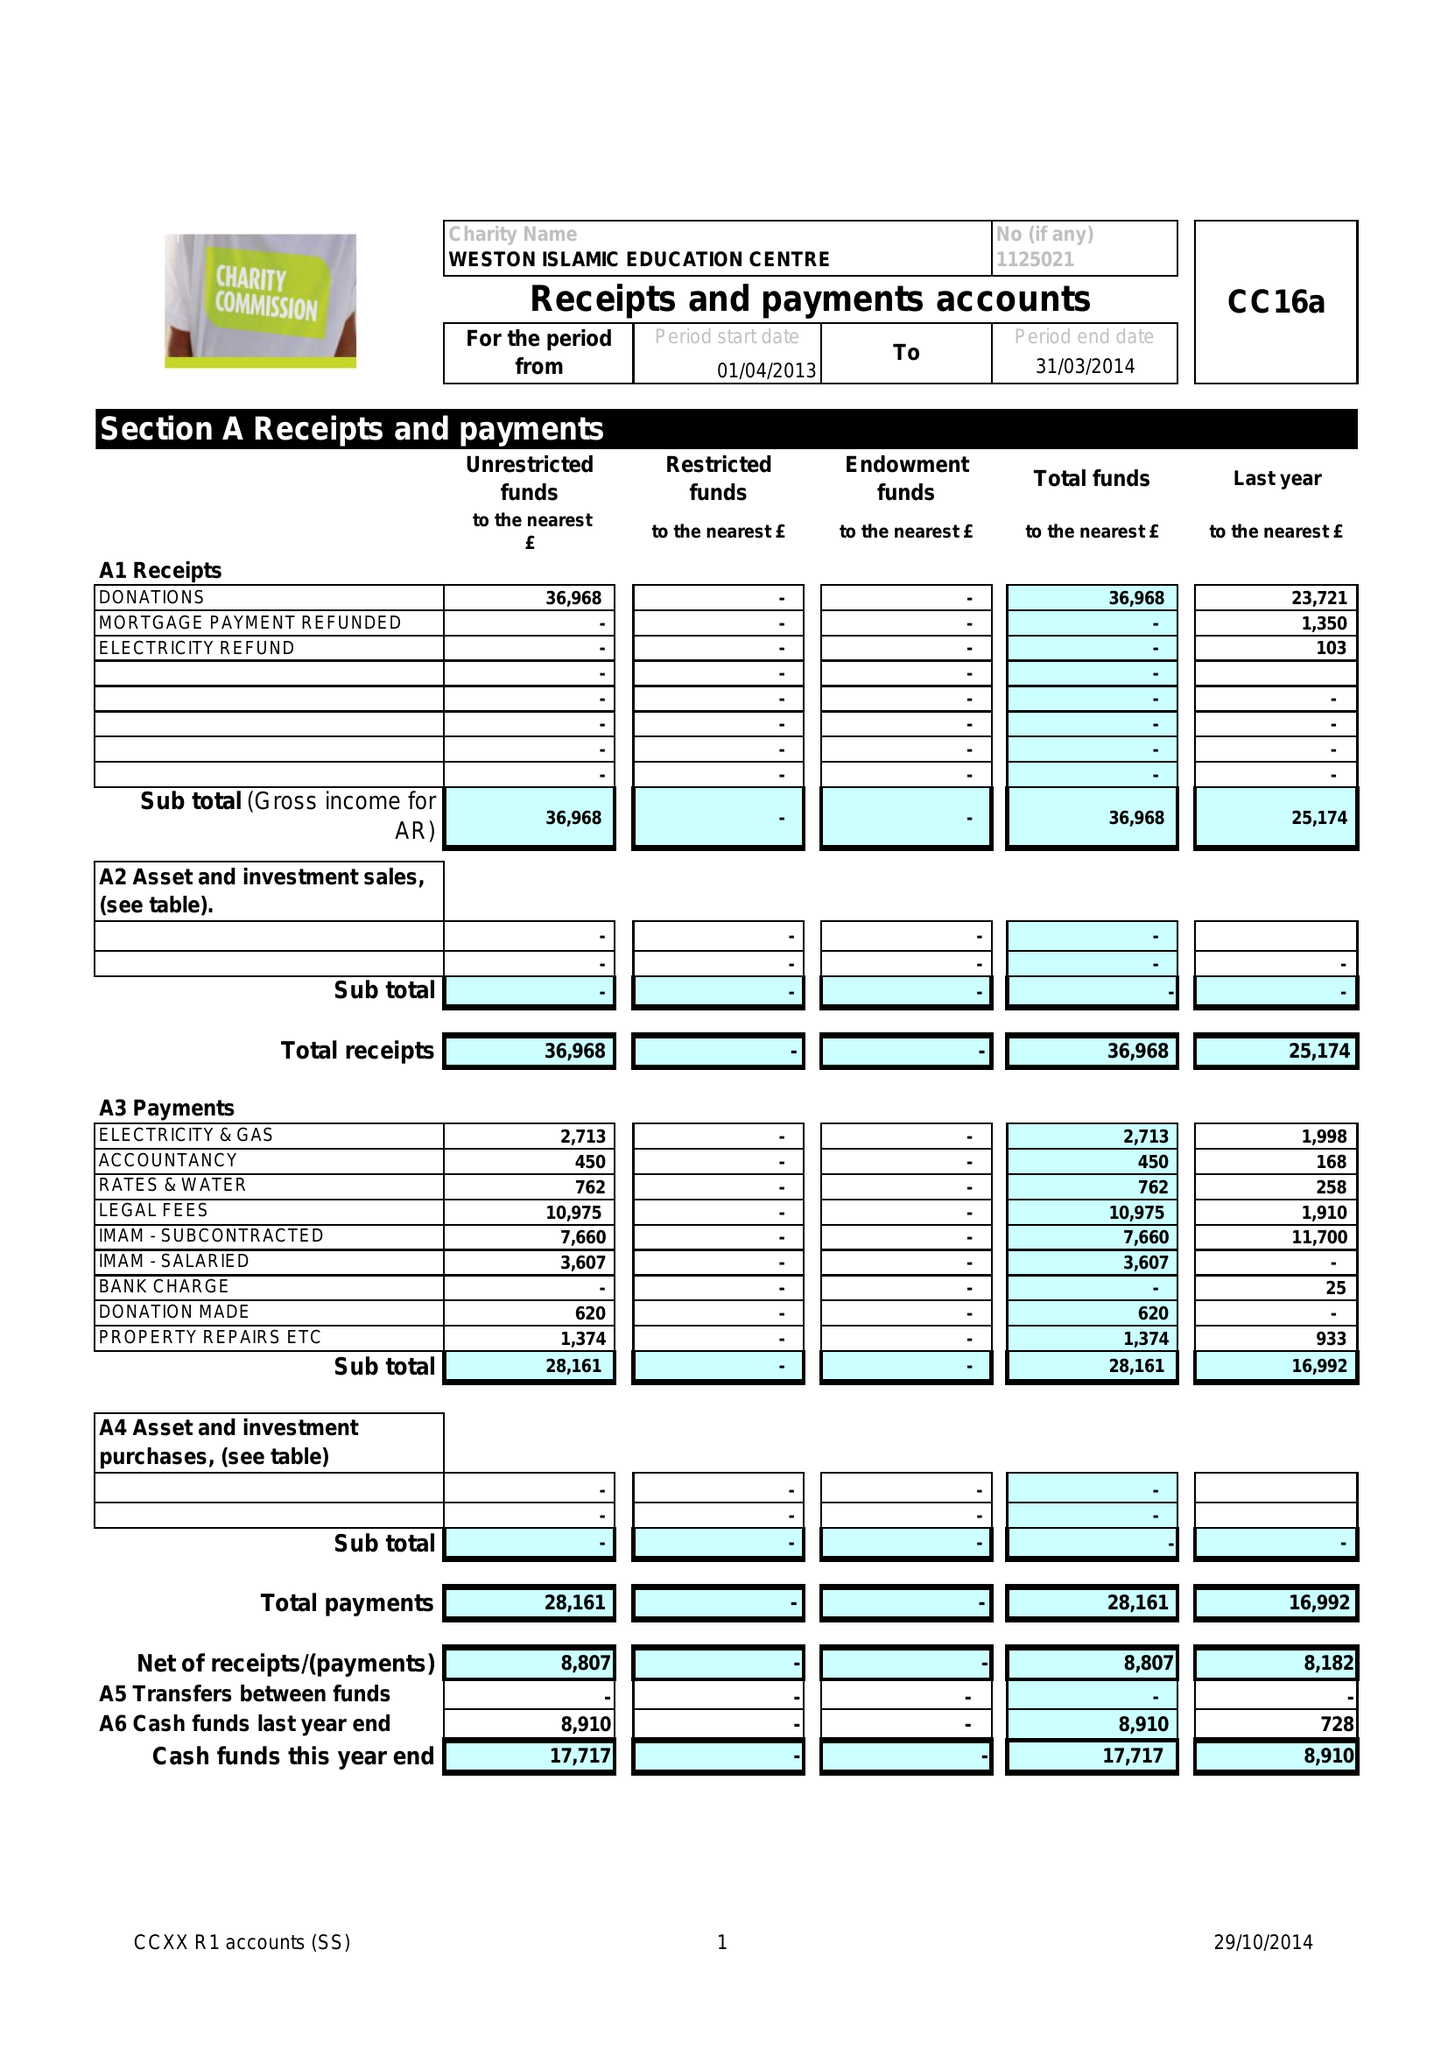What is the value for the spending_annually_in_british_pounds?
Answer the question using a single word or phrase. 28161.00 